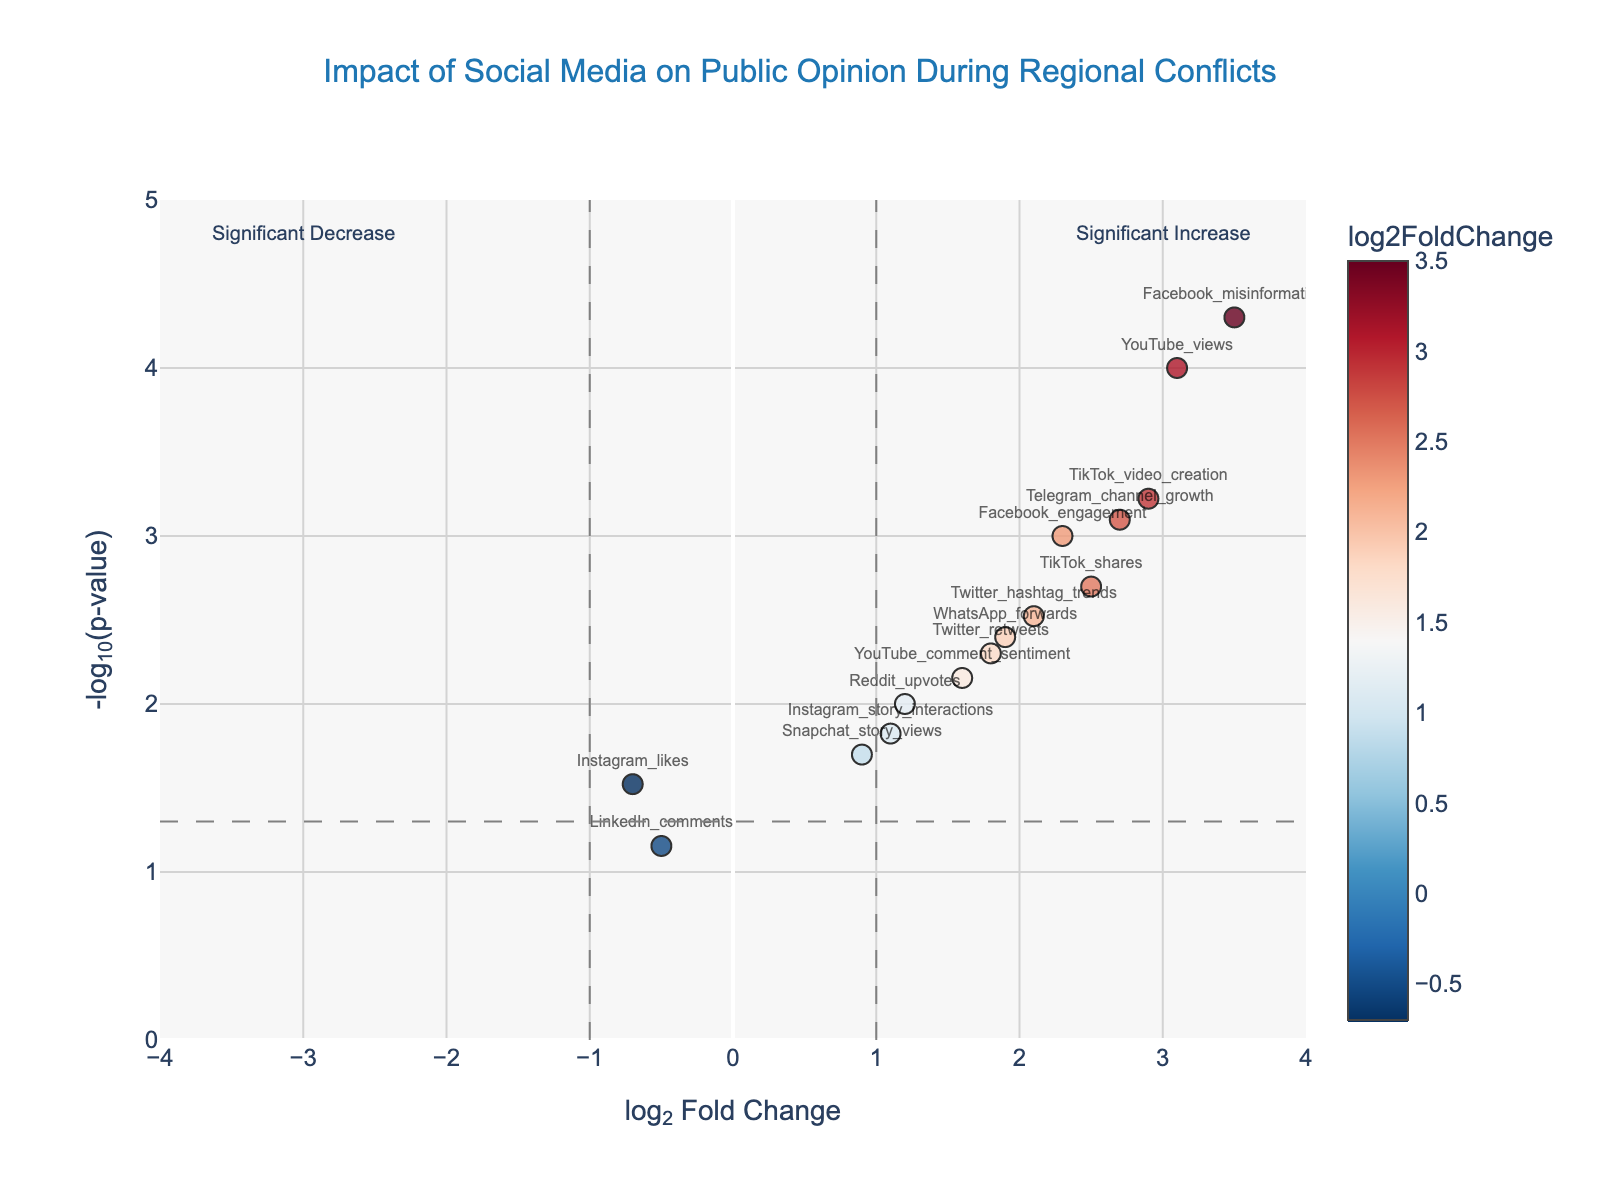What is the title of the plot? The title of the plot is located at the top center of the figure and provides an overview of the content.
Answer: Impact of Social Media on Public Opinion During Regional Conflicts How many social media platforms are represented in the plot by data points? Each platform is represented by a single unique point in the plot based on its name in the data set. Counting each unique data point gives the total number of platforms.
Answer: 15 Which social media platform has the highest log2FoldChange value? The platform with the highest log2FoldChange value is indicated by the data point with the furthest right position along the x-axis. The hover information reveals the exact log2FoldChange value.
Answer: Facebook_misinformation What is the significance threshold for p-values indicated by the dashed horizontal line? The dashed horizontal line marks the significance threshold for p-values in the plot, represented on the y-axis as -log10(p-value).
Answer: 1.3 Which two social media platforms have a log2FoldChange value greater than 2 and highly significant p-values (<0.001)? By looking at data points to the right of the x=2 line and above the y=3 (-log10(0.001)) line, we can identify the platforms that meet these criteria.
Answer: TikTok_video_creation and YouTube_views How does the p-value of Facebook_misinformation compare to Facebook_engagement? Comparing their positions along the y-axis, where Facebook_misinformation is slightly higher than Facebook_engagement indicates a lower p-value for Facebook_misinformation.
Answer: Facebook_misinformation has a lower p-value Which social media platform shows a negative log2FoldChange value but with a significant p-value (<0.05)? The point representing the platform with a negative log2FoldChange is on the left-half of the x-axis. The significance is determined if the point is above the y=1.3 line (p-value <0.05).
Answer: Instagram_likes Are there any platforms with non-significant p-values (greater than 0.05), and if so, which one(s)? Non-significant p-values are represented by points below the y=1.3 line, as this line corresponds to a p-value of 0.05.
Answer: LinkedIn_comments Which platform has the closest log2FoldChange value to 1? By inspecting the data points nearest to the x=1 line, the hover information helps identify the specific platform.
Answer: WhatsApp_forwards What is the color scale used to represent log2FoldChange in the plot? The colors of the data points represent the log2FoldChange values, which are indicated by the color scale on the right side of the plot.
Answer: RdBu_r 